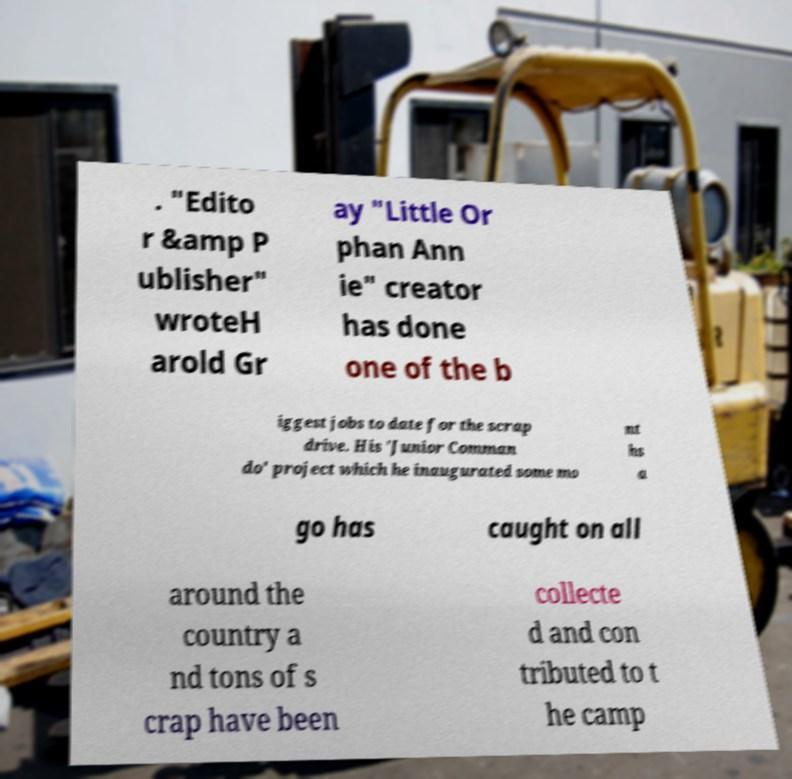Please read and relay the text visible in this image. What does it say? . "Edito r &amp P ublisher" wroteH arold Gr ay "Little Or phan Ann ie" creator has done one of the b iggest jobs to date for the scrap drive. His 'Junior Comman do' project which he inaugurated some mo nt hs a go has caught on all around the country a nd tons of s crap have been collecte d and con tributed to t he camp 